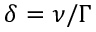<formula> <loc_0><loc_0><loc_500><loc_500>\delta = \nu / \Gamma</formula> 